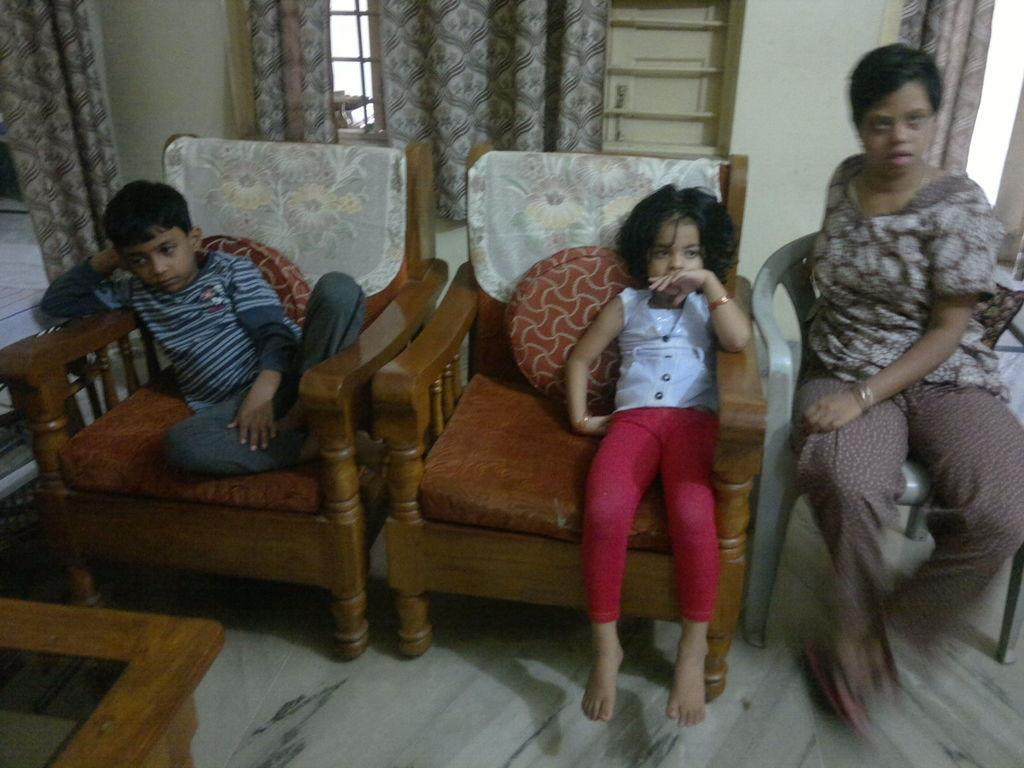How many people are in the image? There are three persons in the image. What are the persons doing in the image? The persons are sitting on a chair. What can be seen near the window in the image? There is a curtain near the window in the image. What is in front of one of the persons? There is a table in front of one of the persons. What is used to provide comfort on the chairs? There are pillows on the chairs. What type of advertisement can be seen on the table in the image? There is no advertisement present on the table in the image. 